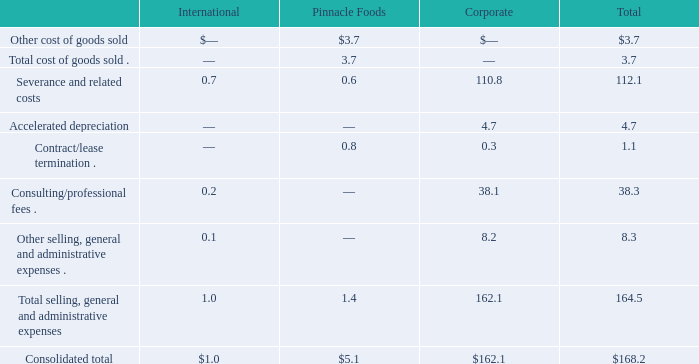Notes to Consolidated Financial Statements - (Continued) Fiscal Years Ended May 26, 2019, May 27, 2018, and May 28, 2017 (columnar dollars in millions except per share amounts)  During fiscal 2019, we recognized the following pre-tax expenses for the Pinnacle Integration Restructuring Plan:
Included in the above results are $163.5 million of charges that have resulted or will result in cash outflows and $4.7 million in non-cash charges.
What does the table show us in the fiscal year 2019? Pre-tax expenses for the pinnacle integration restructuring plan. How much were the non-cash charges included in the pre-tax expenses? $4.7 million. What were the consolidated totals of International and Pinnacle Foods, respectively?
Answer scale should be: million. $1.0, $5.1. What is the proportion of cash charges that have resulted or will result in cash outflows over total consolidated pre-tax expenses? 163.5/168.2 
Answer: 0.97. What is the proportion of accelerated depreciation, contract/lease termination, and consulting/professional fees over the consolidated total in the Corporate segment? (4.7+0.3+38.1)/162.1 
Answer: 0.27. What is the ratio of International’s consolidated total to Pinnacle Foods’ consolidated total? 1.0/5.1 
Answer: 0.2. 